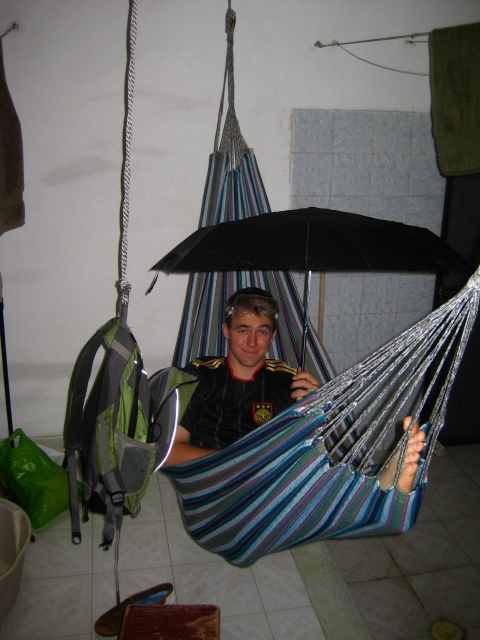<image>Is there a bed frame nearby? No, there is no bed frame nearby. Is there a bed frame nearby? There is no bed frame nearby. It is also unknown if there is a bed frame nearby. 